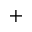<formula> <loc_0><loc_0><loc_500><loc_500>+</formula> 